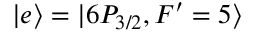<formula> <loc_0><loc_0><loc_500><loc_500>| e \rangle = | 6 P _ { 3 / 2 } , F ^ { \prime } = 5 \rangle</formula> 